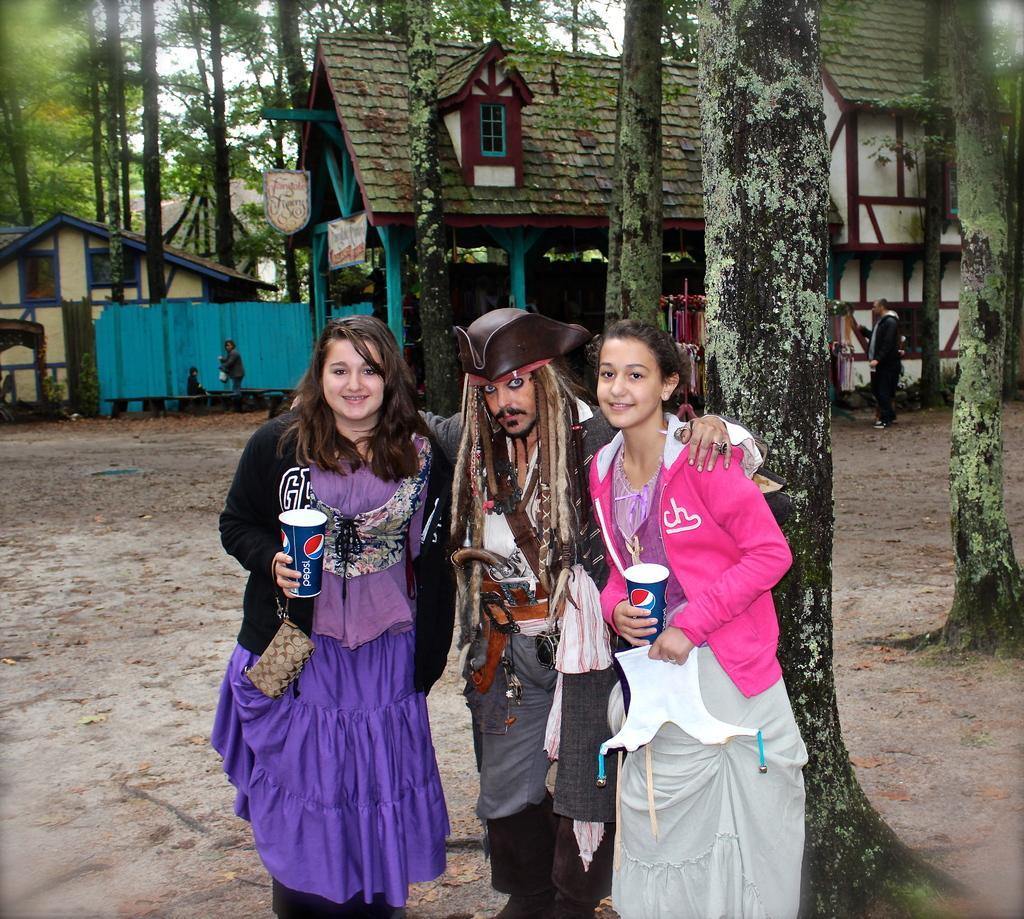In one or two sentences, can you explain what this image depicts? In the picture we can see two women and a man wearing different costume standing together and posing for a photograph, woman holding glasses in their hands and in the background of the picture there are some houses, trees. 